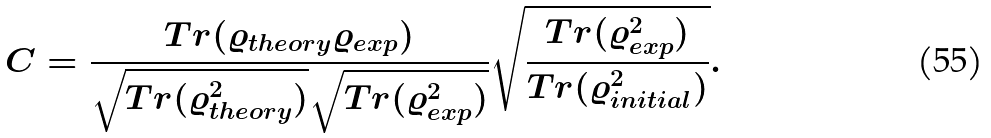<formula> <loc_0><loc_0><loc_500><loc_500>C = \frac { T r ( \varrho _ { t h e o r y } \varrho _ { e x p } ) } { \sqrt { T r ( \varrho _ { t h e o r y } ^ { 2 } ) } \sqrt { T r ( \varrho _ { e x p } ^ { 2 } ) } } \sqrt { \frac { T r ( \varrho _ { e x p } ^ { 2 } ) } { T r ( \varrho _ { i n i t i a l } ^ { 2 } ) } } .</formula> 